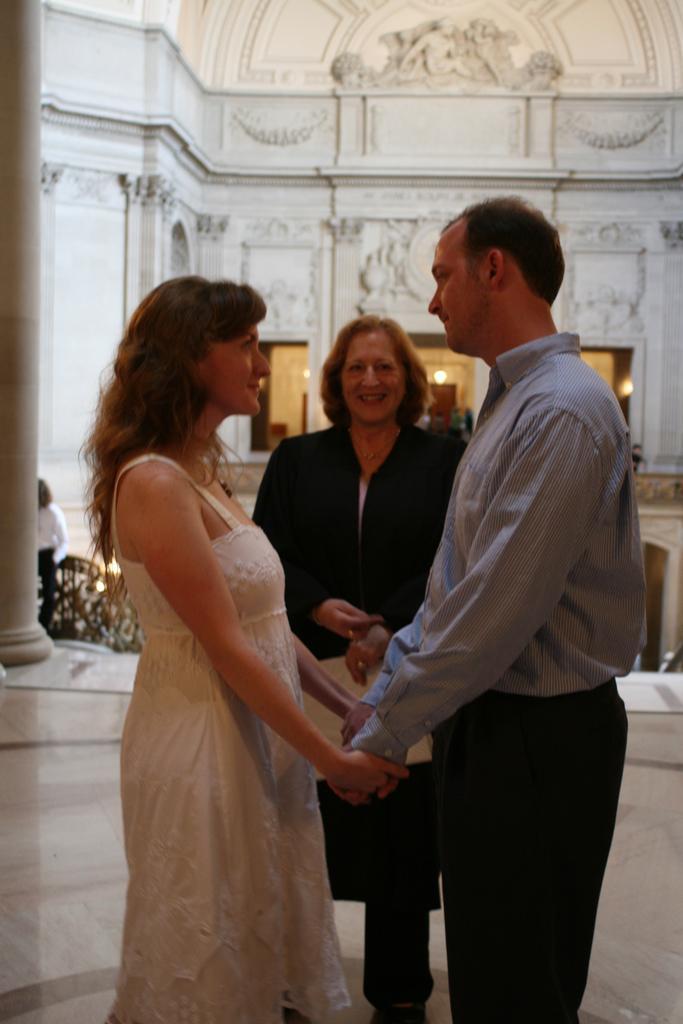Could you give a brief overview of what you see in this image? Here a man and two women are standing, this is a building. 